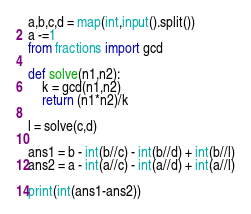<code> <loc_0><loc_0><loc_500><loc_500><_Python_>a,b,c,d = map(int,input().split())
a -=1
from fractions import gcd

def solve(n1,n2):
    k = gcd(n1,n2)
    return (n1*n2)/k

l = solve(c,d)

ans1 = b - int(b//c) - int(b//d) + int(b//l)
ans2 = a - int(a//c) - int(a//d) + int(a//l)

print(int(ans1-ans2))</code> 